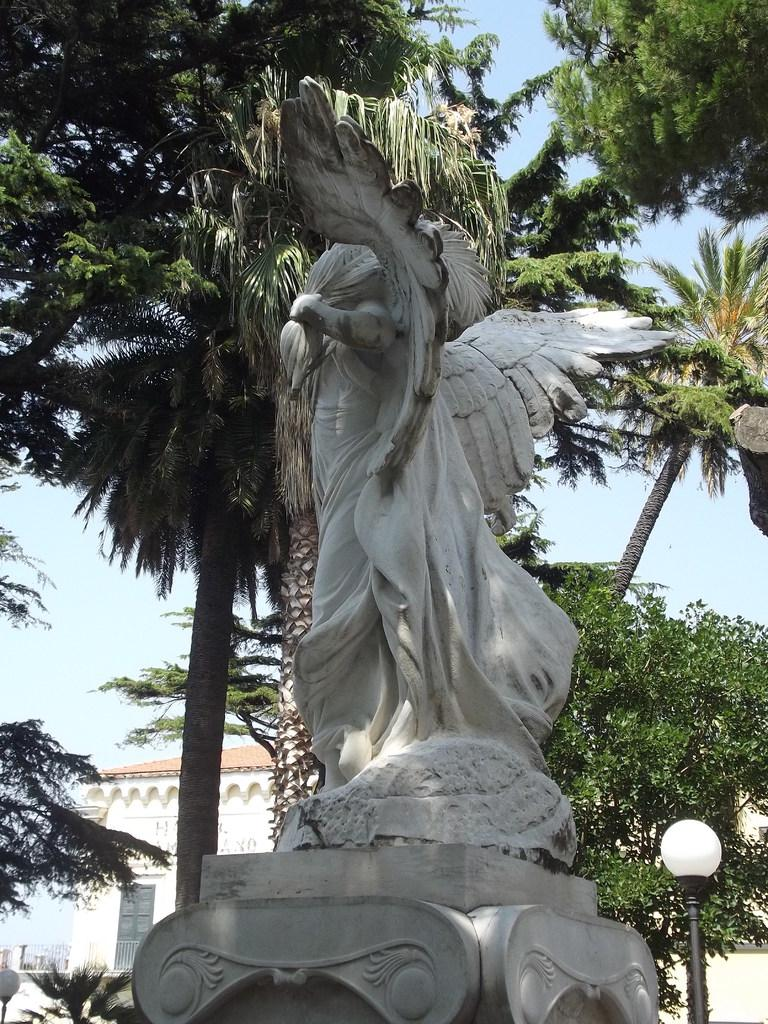What is the main subject in the middle of the image? There is a statue in the middle of the image. What is located beside the statue? There is a street light beside the statue. What type of vegetation is behind the statue? There are trees behind the statue. What can be seen in the background of the image? There are buildings in the background of the image. What is visible above the statue? The sky is visible above the statue. What brand of toothpaste is being advertised on the statue in the image? There is no toothpaste or advertisement present on the statue in the image. How many babies are sitting on the statue in the image? There are no babies present on the statue in the image. 